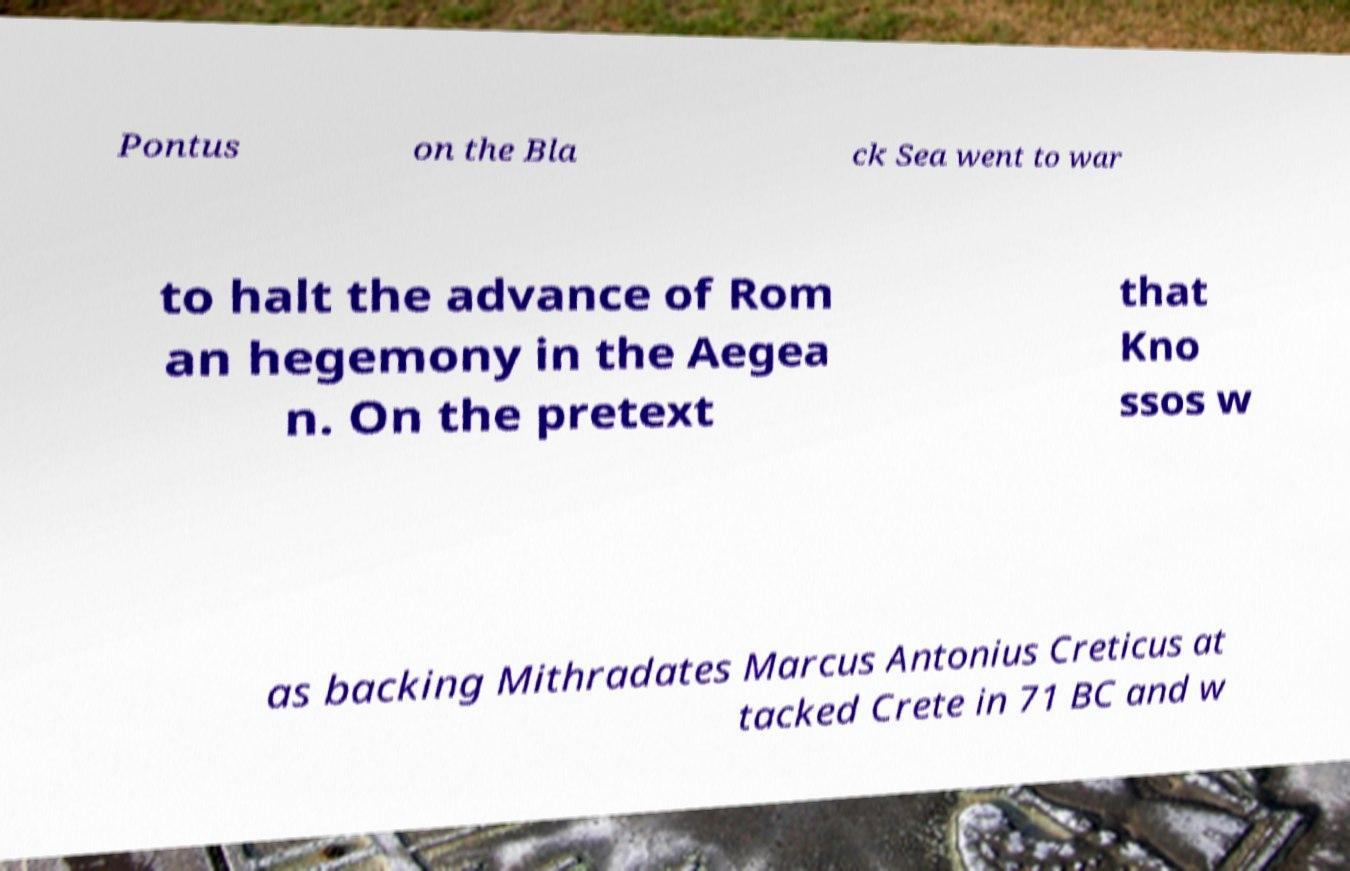Could you assist in decoding the text presented in this image and type it out clearly? Pontus on the Bla ck Sea went to war to halt the advance of Rom an hegemony in the Aegea n. On the pretext that Kno ssos w as backing Mithradates Marcus Antonius Creticus at tacked Crete in 71 BC and w 